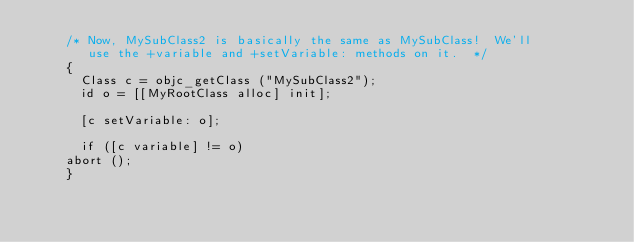<code> <loc_0><loc_0><loc_500><loc_500><_ObjectiveC_>    /* Now, MySubClass2 is basically the same as MySubClass!  We'll
       use the +variable and +setVariable: methods on it.  */
    {
      Class c = objc_getClass ("MySubClass2");
      id o = [[MyRootClass alloc] init];

      [c setVariable: o];
      
      if ([c variable] != o)
	abort ();
    }
    </code> 